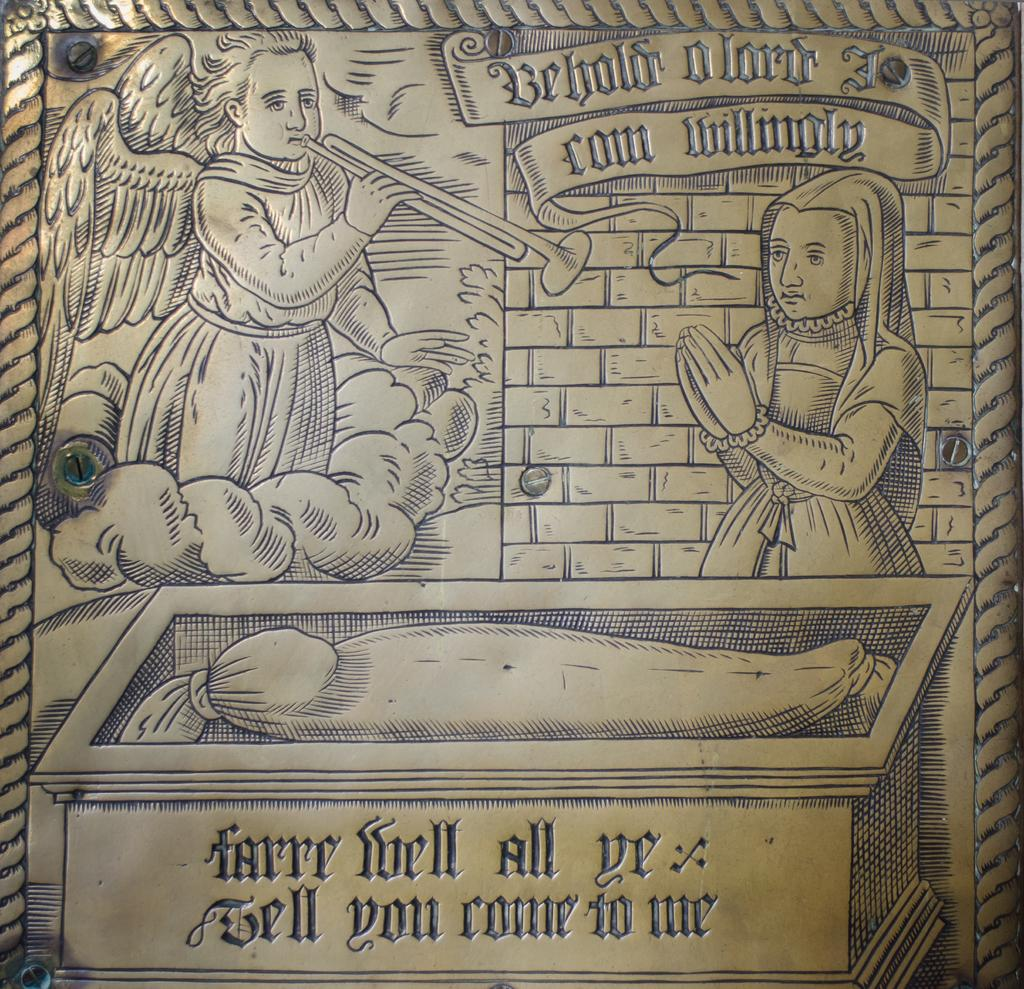What type of object is in the image? There is a metal object in the image. Are there any people on the metal object? Yes, two people are on the metal object. What else can be seen on the metal object? There is a box on the metal object. Is there any writing or text on the metal object? Yes, there is text visible on the metal object. What type of milk is being poured from the hose in the image? There is no milk or hose present in the image. 